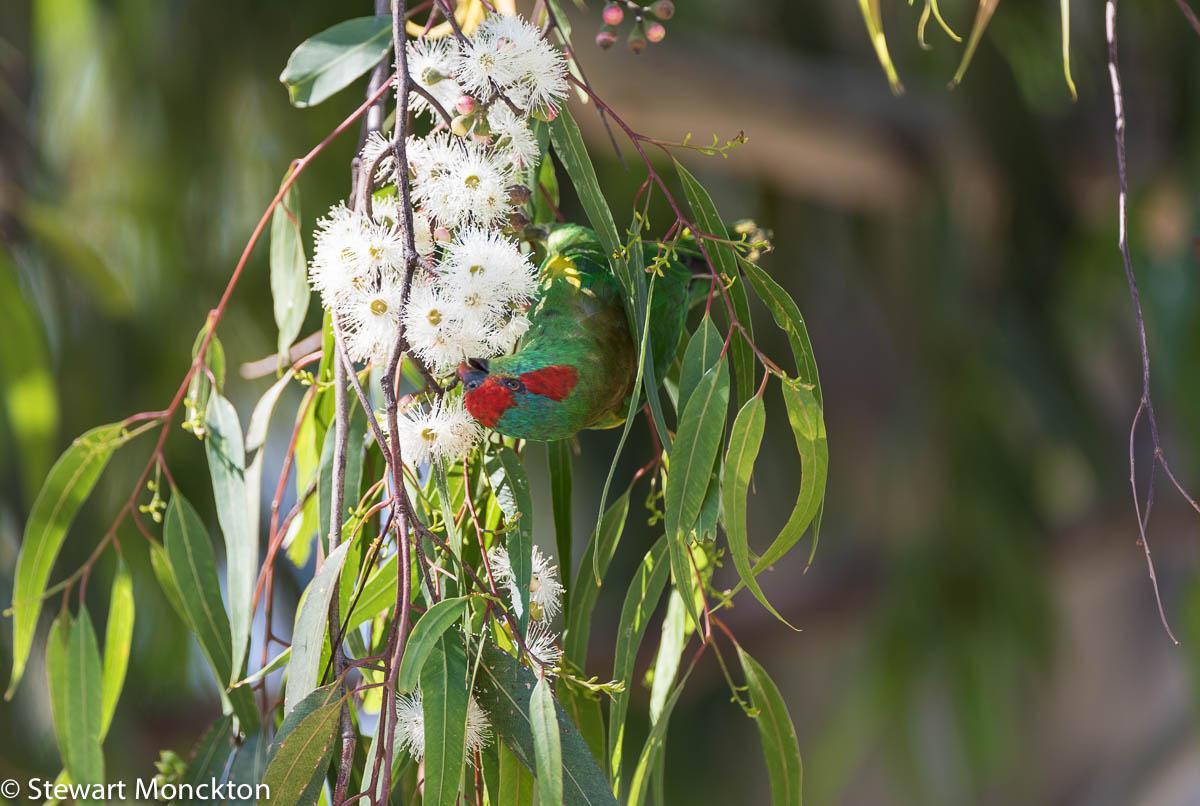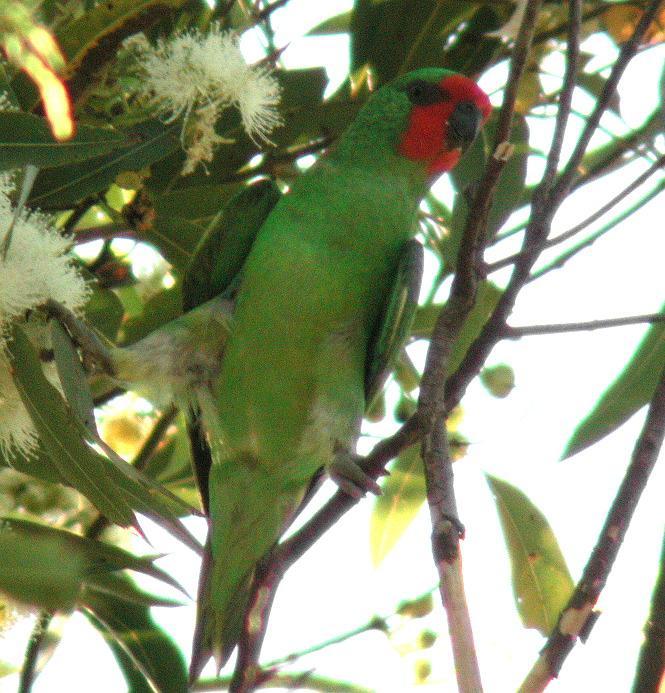The first image is the image on the left, the second image is the image on the right. Analyze the images presented: Is the assertion "there are 4 parrots in the image pair" valid? Answer yes or no. No. The first image is the image on the left, the second image is the image on the right. Assess this claim about the two images: "There are four parrots.". Correct or not? Answer yes or no. No. 